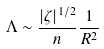Convert formula to latex. <formula><loc_0><loc_0><loc_500><loc_500>\Lambda \sim \frac { | \zeta | ^ { 1 / 2 } } { n } \frac { 1 } { R ^ { 2 } }</formula> 